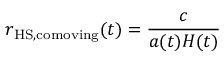Convert formula to latex. <formula><loc_0><loc_0><loc_500><loc_500>r _ { { H S } , c o m o v i n g } ( t ) = { \frac { c } { a ( t ) H ( t ) } }</formula> 